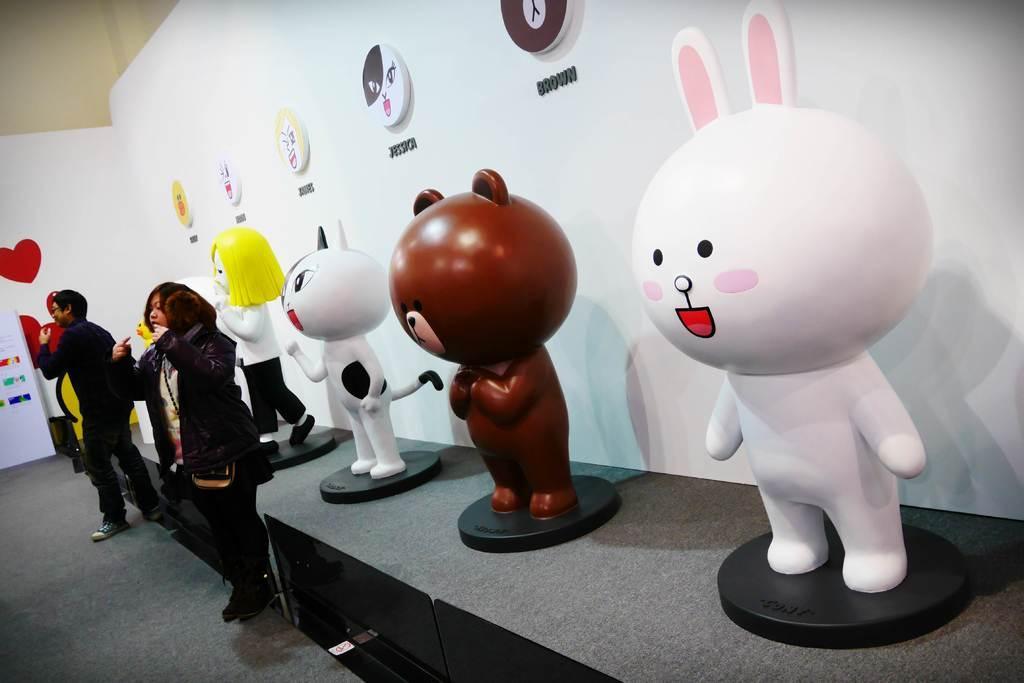Could you give a brief overview of what you see in this image? In this image we can see some dolls which are placed on the table. We can also see a man and a woman standing beside them. On the backside we can see a sticker and some frames to a wall. 